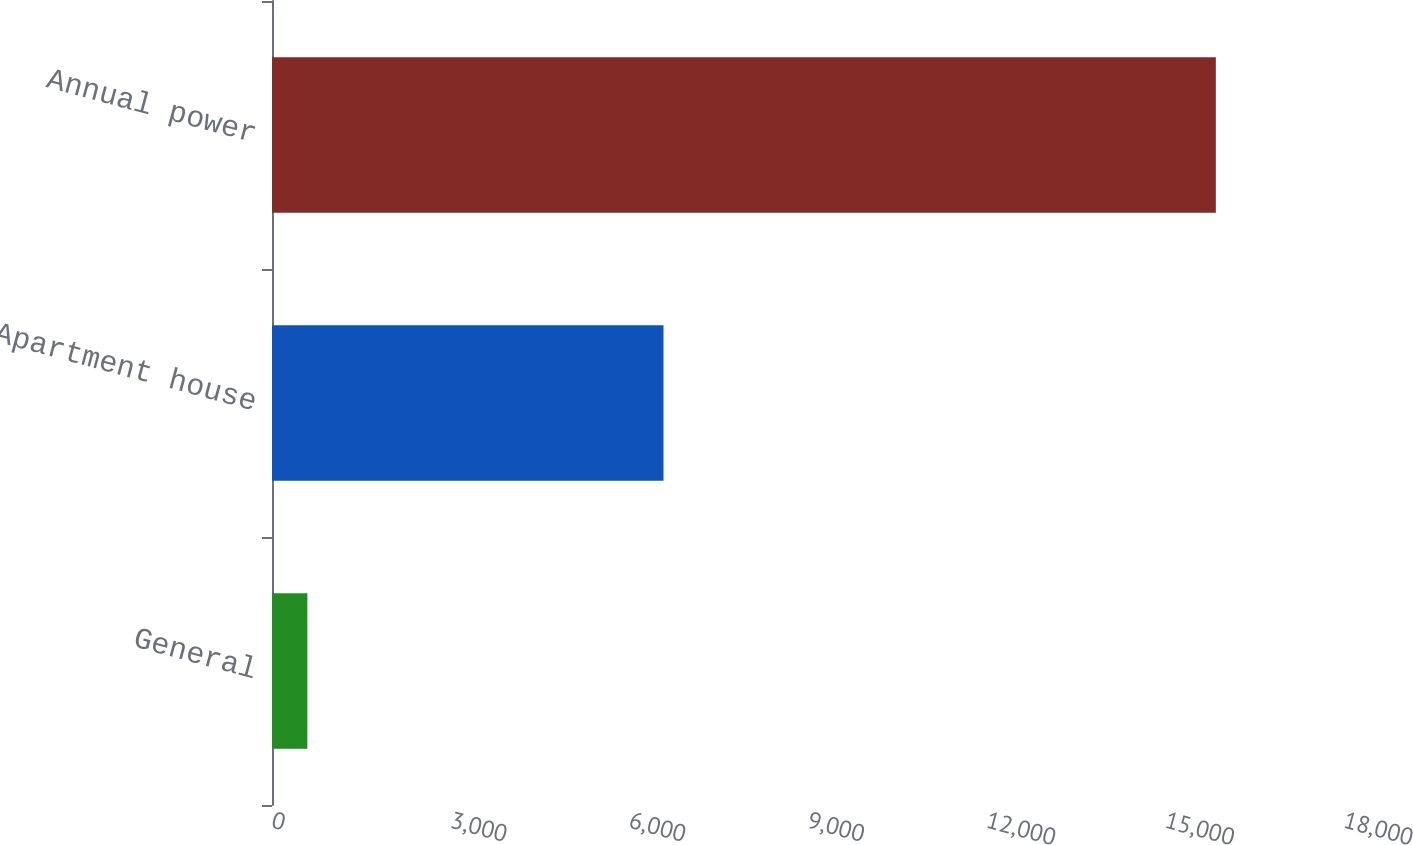<chart> <loc_0><loc_0><loc_500><loc_500><bar_chart><fcel>General<fcel>Apartment house<fcel>Annual power<nl><fcel>594<fcel>6574<fcel>15848<nl></chart> 